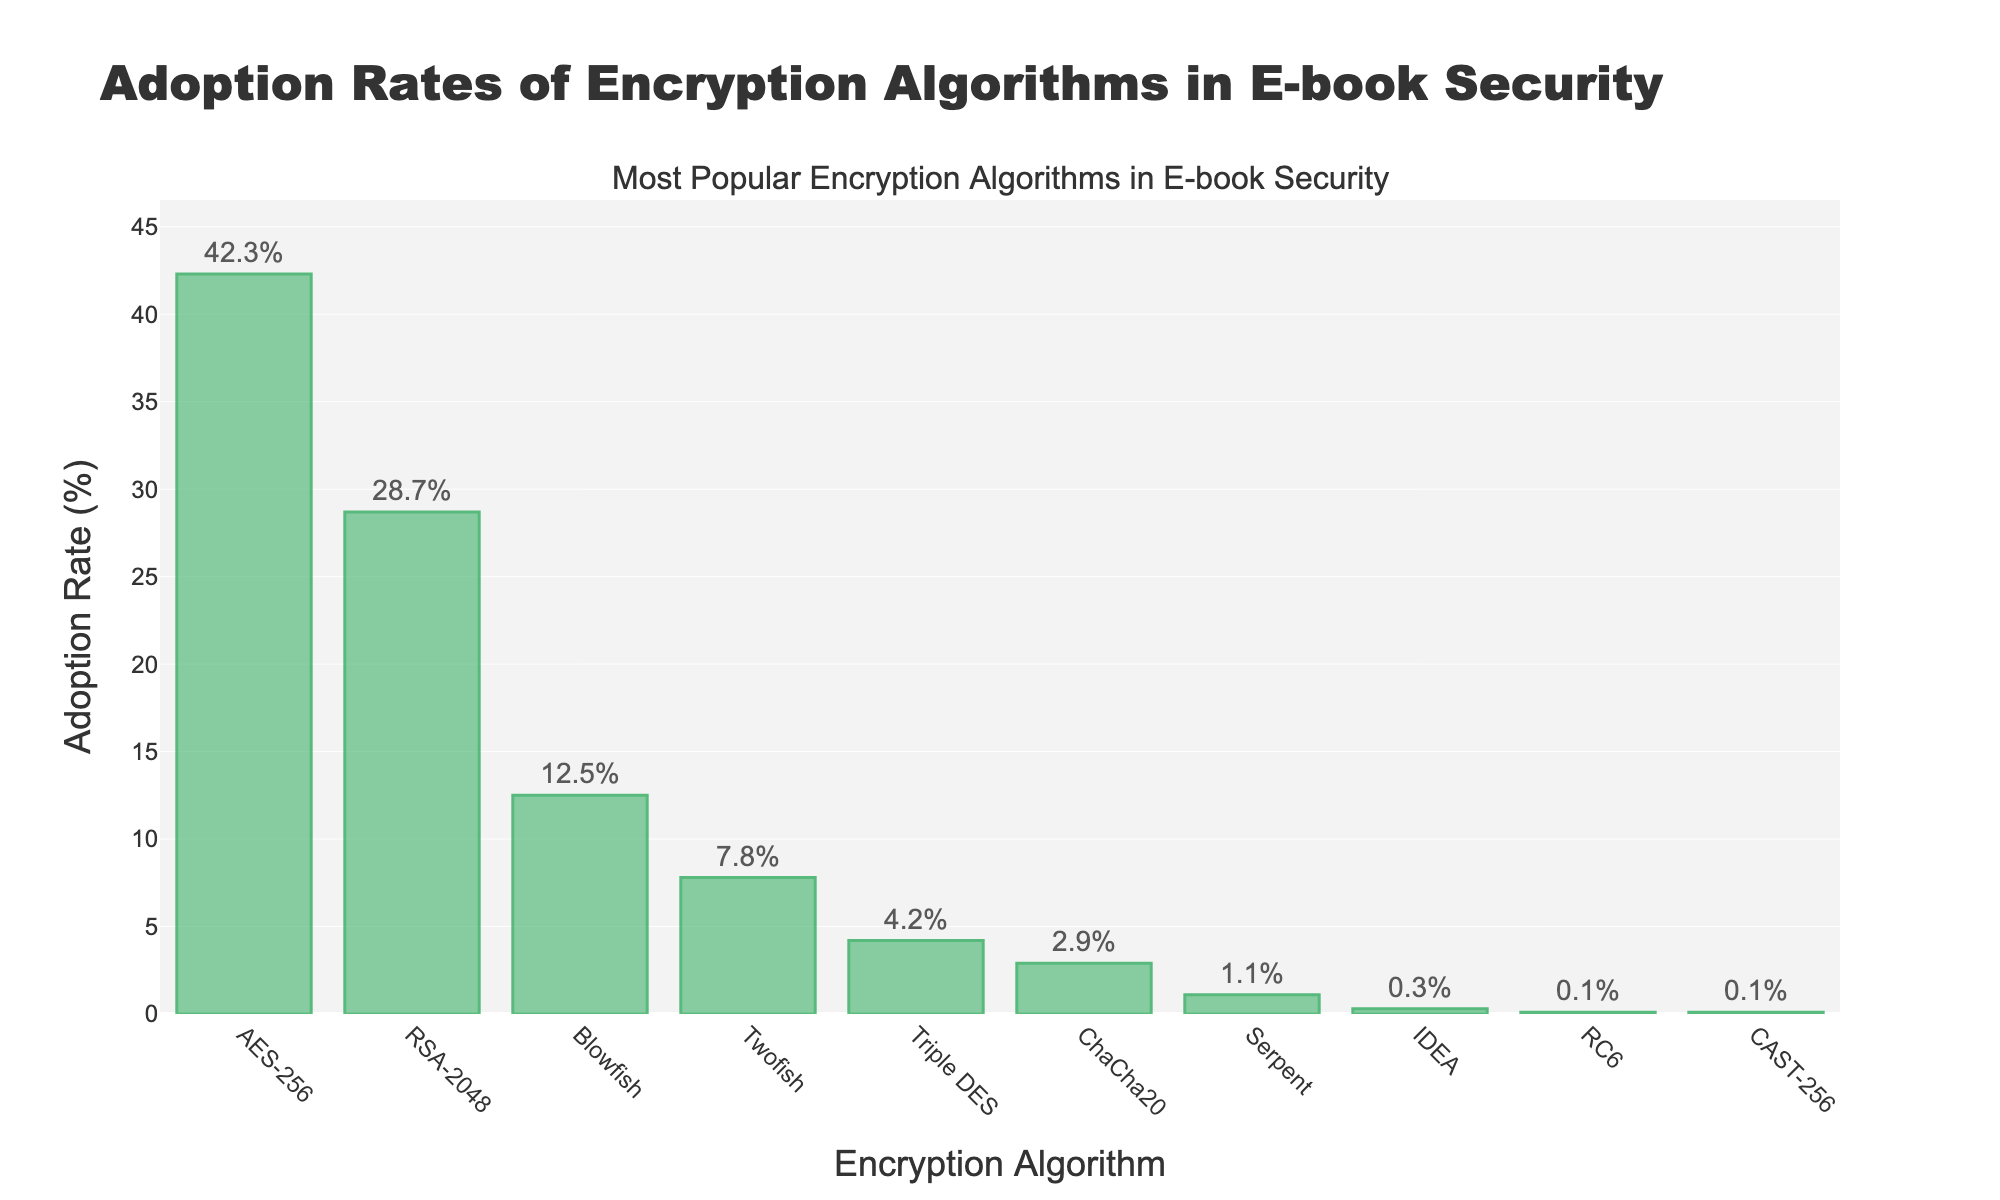Which encryption algorithm has the highest adoption rate? Looking at the figure, the tallest bar corresponds to the algorithm AES-256, which indicates it has the highest adoption rate.
Answer: AES-256 What is the difference in adoption rates between the most popular and the least popular encryption algorithms? The adoption rate of the most popular algorithm (AES-256) is 42.3%, and the least popular algorithms (RC6 and CAST-256) have adoption rates of 0.1%. The difference is calculated as 42.3% - 0.1%.
Answer: 42.2% Which algorithms have an adoption rate of less than 5%? From the figure, the bars representing Triple DES, ChaCha20, Serpent, IDEA, RC6, and CAST-256 are all below the 5% mark.
Answer: Triple DES, ChaCha20, Serpent, IDEA, RC6, CAST-256 How many algorithms have an adoption rate higher than 10%? By observing the height of the bars, we can see that AES-256, RSA-2048, and Blowfish each have adoption rates above 10%. Therefore, there are 3 such algorithms.
Answer: 3 What is the combined adoption rate of RSA-2048 and Twofish? RSA-2048 has an adoption rate of 28.7% and Twofish has 7.8%. Their combined adoption rate is 28.7% + 7.8%.
Answer: 36.5% Is the adoption rate of Blowfish greater than the combined adoption rates of Serpent and IDEA? Blowfish has an adoption rate of 12.5%. The combined adoption rates of Serpent and IDEA are 1.1% + 0.3% = 1.4%. Since 12.5% is greater than 1.4%, Blowfish's adoption rate is indeed greater.
Answer: Yes Which algorithm has a slightly higher adoption rate - Triple DES or ChaCha20? By comparing the lengths of the bars, Triple DES has an adoption rate of 4.2%, while ChaCha20 has 2.9%. Hence, Triple DES has a slightly higher adoption rate.
Answer: Triple DES What is the difference in adoption rates between AES-256 and RSA-2048? AES-256 has an adoption rate of 42.3% and RSA-2048 has 28.7%. The difference is calculated as 42.3% - 28.7%.
Answer: 13.6% What percentage of the total adoption rate is accounted for by the top three algorithms? The total adoption rate for the top three algorithms (AES-256, RSA-2048, and Blowfish) is 42.3% + 28.7% + 12.5% = 83.5%. Since the total rate is 100%, the top three account for 83.5% of the total.
Answer: 83.5% Which algorithms have adoption rates closest to the median value? There are 10 algorithms, so the median value would be the average of the 5th and 6th ranked algorithms. The 5th algorithm is Triple DES with 4.2% and the 6th is ChaCha20 with 2.9%. The average is (4.2 + 2.9)/2 = 3.55%. Therefore, these are the ones closest to the median value of 3.55%.
Answer: Triple DES, ChaCha20 